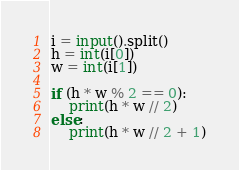Convert code to text. <code><loc_0><loc_0><loc_500><loc_500><_Python_>i = input().split()
h = int(i[0])
w = int(i[1])

if (h * w % 2 == 0):
    print(h * w // 2)
else:
    print(h * w // 2 + 1)</code> 